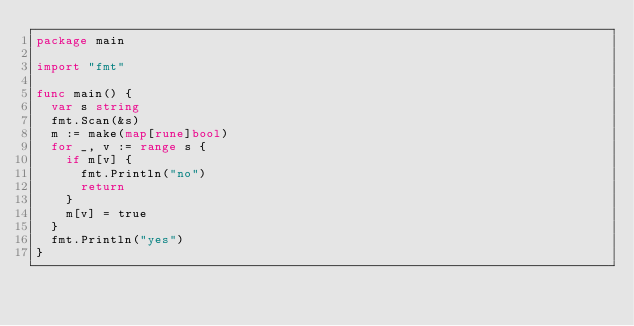Convert code to text. <code><loc_0><loc_0><loc_500><loc_500><_Go_>package main

import "fmt"

func main() {
	var s string
	fmt.Scan(&s)
	m := make(map[rune]bool)
	for _, v := range s {
		if m[v] {
			fmt.Println("no")
			return
		}
		m[v] = true
	}
	fmt.Println("yes")
}
</code> 